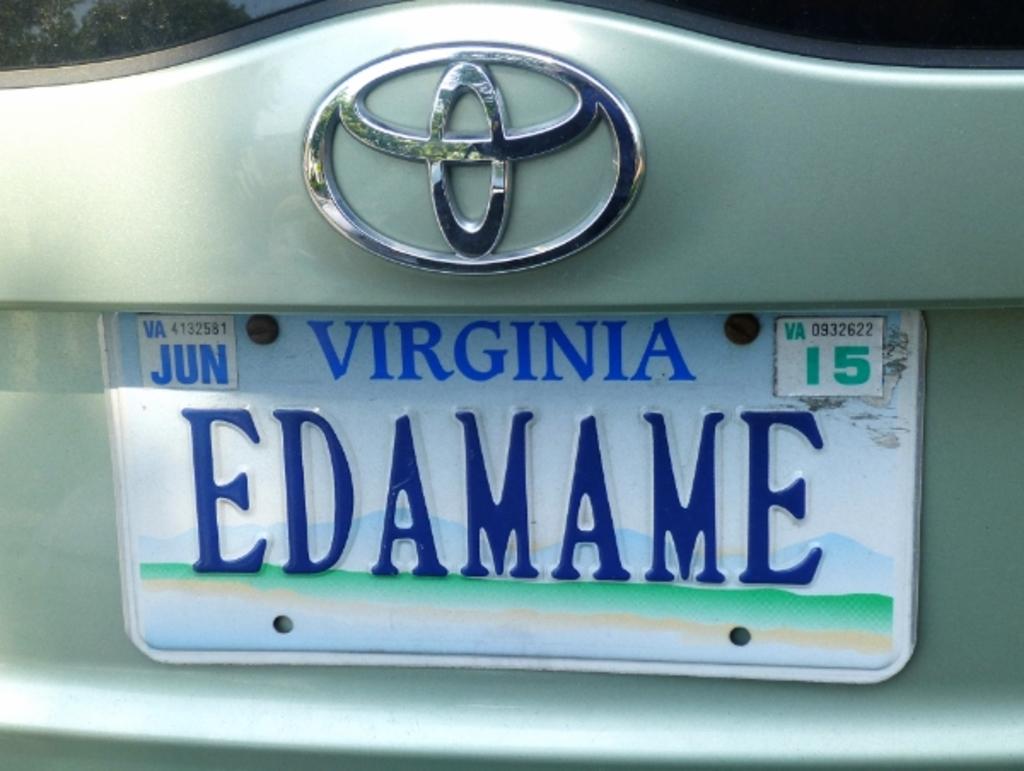What is the license plate number?
Make the answer very short. Edamame. 